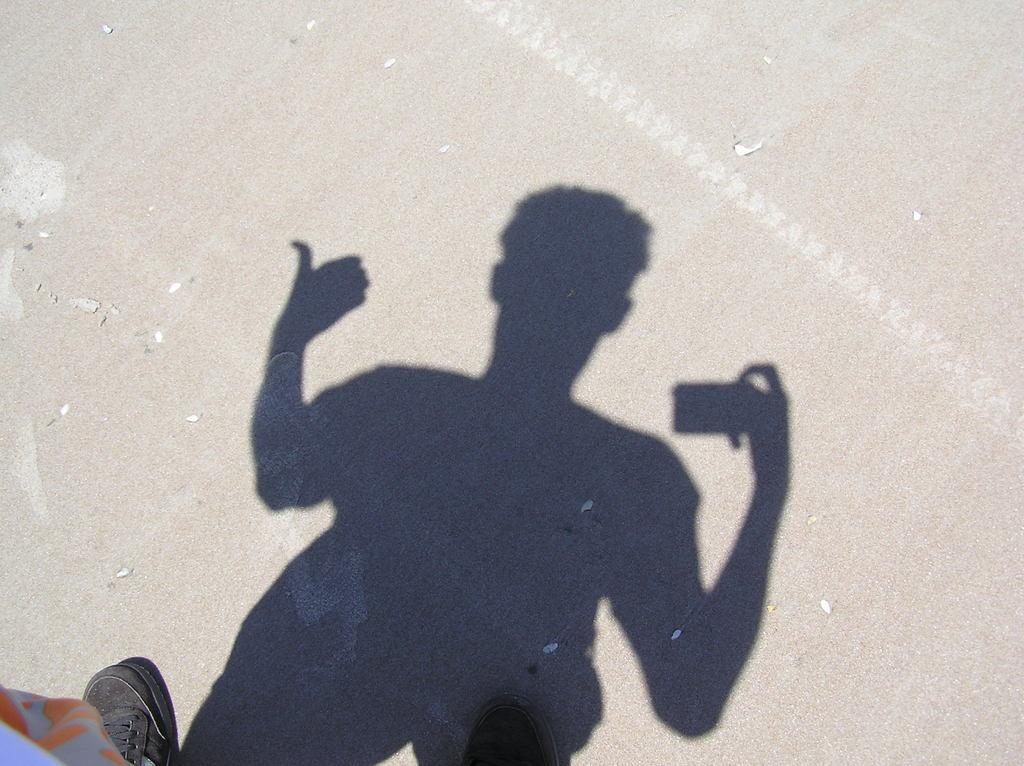What object is present in the image? There is a shoe in the image. What else can be seen in the image besides the shoe? There is a shadow of a person in the image. What type of ice is visible in the jar in the image? There is no jar or ice present in the image. How many bits can be seen in the image? There are no bits visible in the image. 